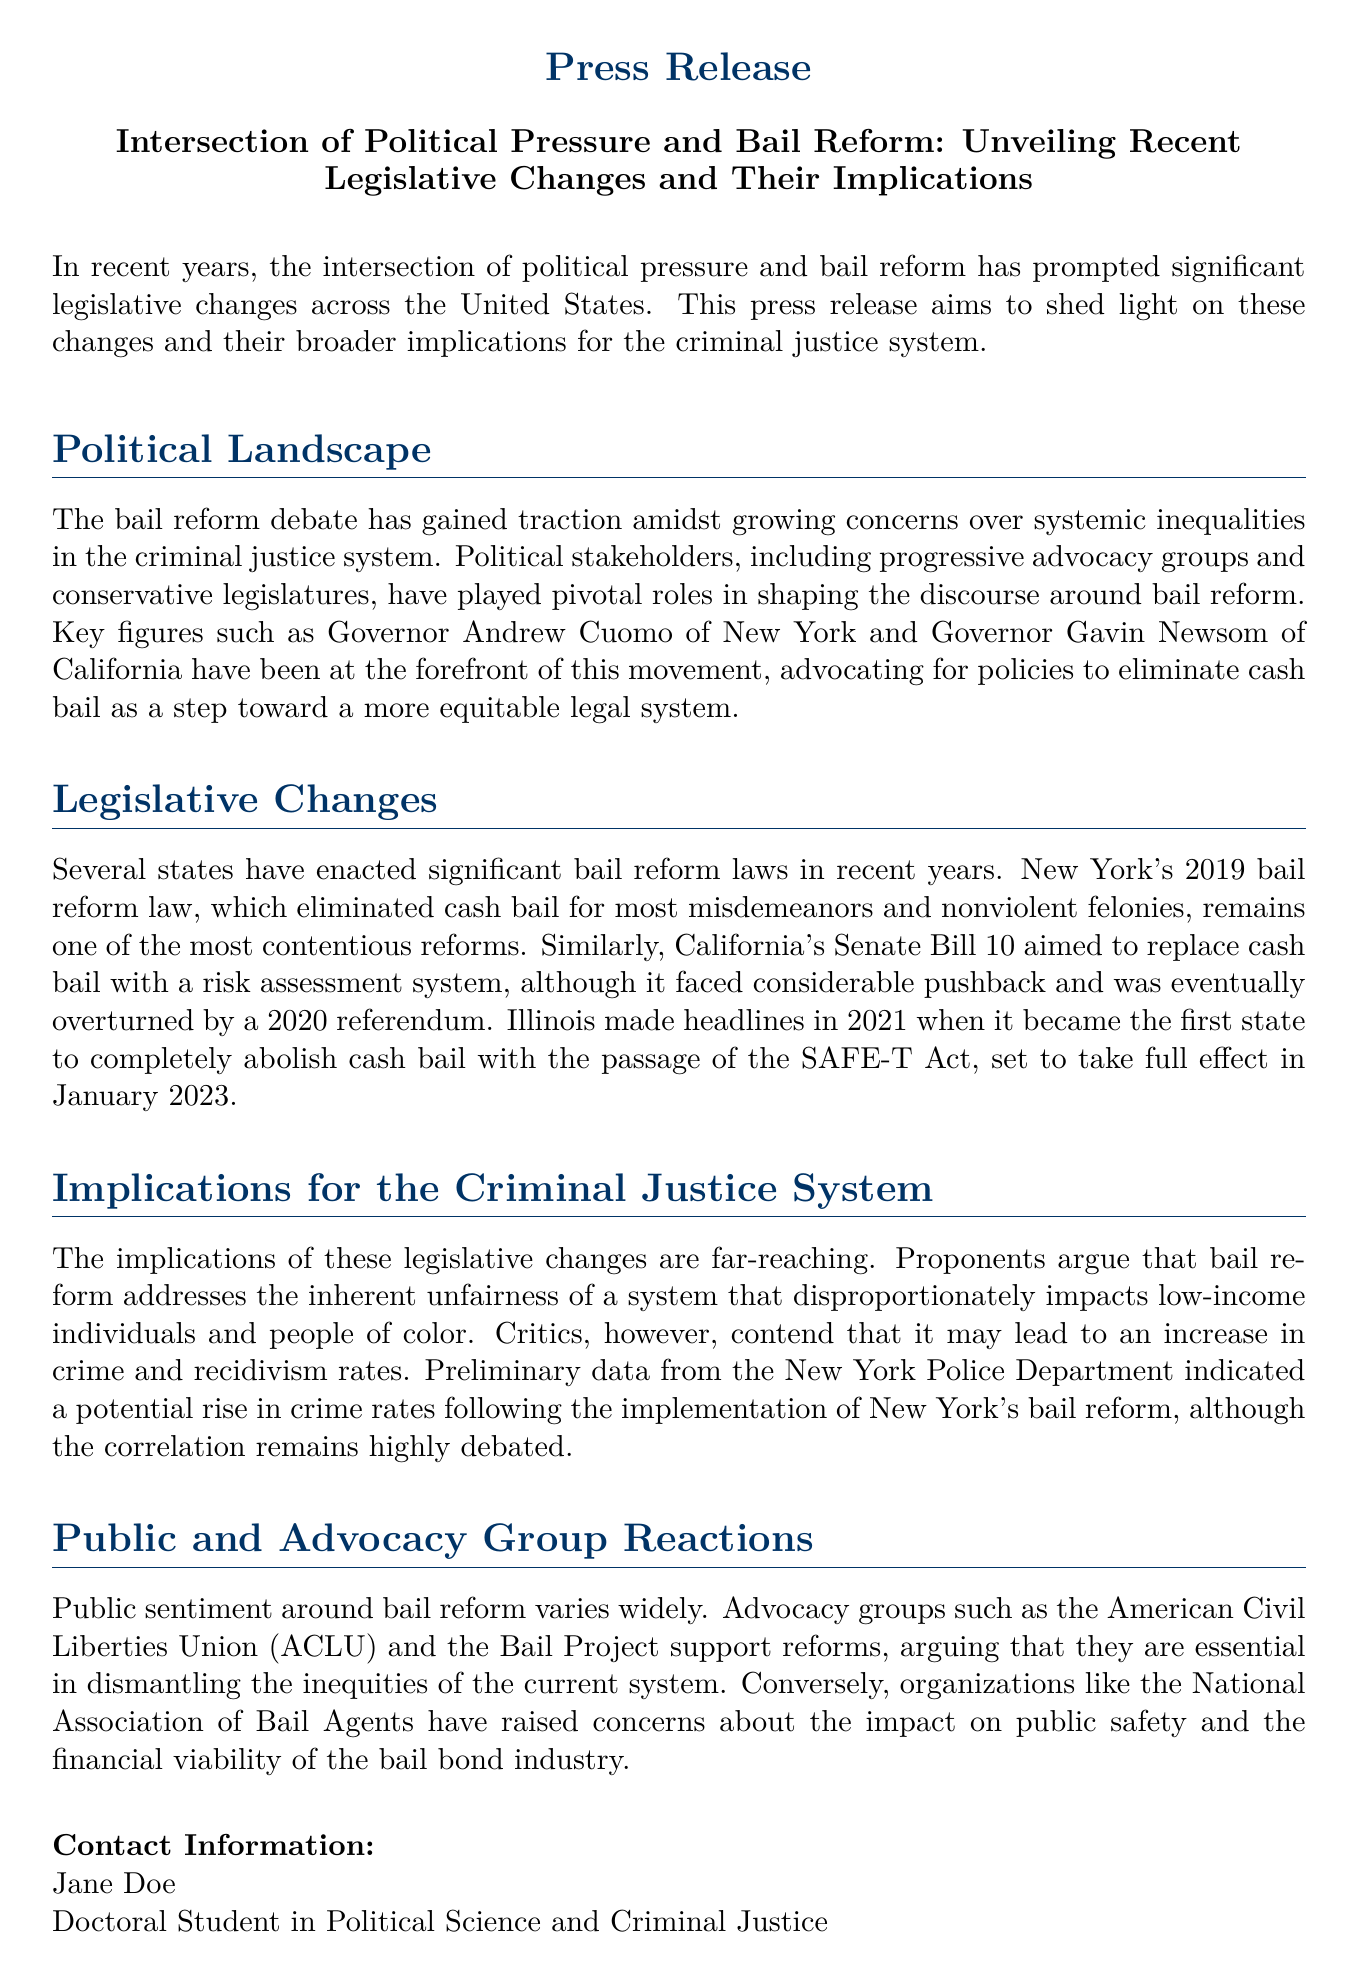What is the title of the press release? The title is stated clearly at the beginning of the document, which addresses recent legislative changes and their implications regarding bail reform.
Answer: Intersection of Political Pressure and Bail Reform: Unveiling Recent Legislative Changes and Their Implications Who is a key figure in the bail reform movement mentioned in New York? The press release references influential political stakeholders that have shaped the discourse, specifically mentioning notable governors.
Answer: Governor Andrew Cuomo What was the outcome of California's Senate Bill 10? The press release details significant legislative actions, including the fate of California's attempts at bail reform, emphasizing the public's response.
Answer: Overturned by a 2020 referendum When did Illinois abolish cash bail? The document provides specific timelines related to legislative enactments, particularly the significant actions taken by states like Illinois.
Answer: 2021 What advocacy group supports bail reform? The press release highlights various stakeholders' positions regarding bail reform, specifically naming organizations that advocate for such changes.
Answer: American Civil Liberties Union (ACLU) What are the proponents of bail reform arguing it addresses? The document presents arguments from various sides regarding the implications of bail reform, particularly its impact on specific demographics.
Answer: Systemic inequalities What does the ACLU argue is essential? The advocacy group's belief regarding the necessity of legislative changes is clearly stated in the press release.
Answer: Dismantling the inequities of the current system What was not included in the press release? The press release presents structured information about connections in politics and reforms but does not discuss even broader issues beyond this context.
Answer: Financial impacts on individuals 